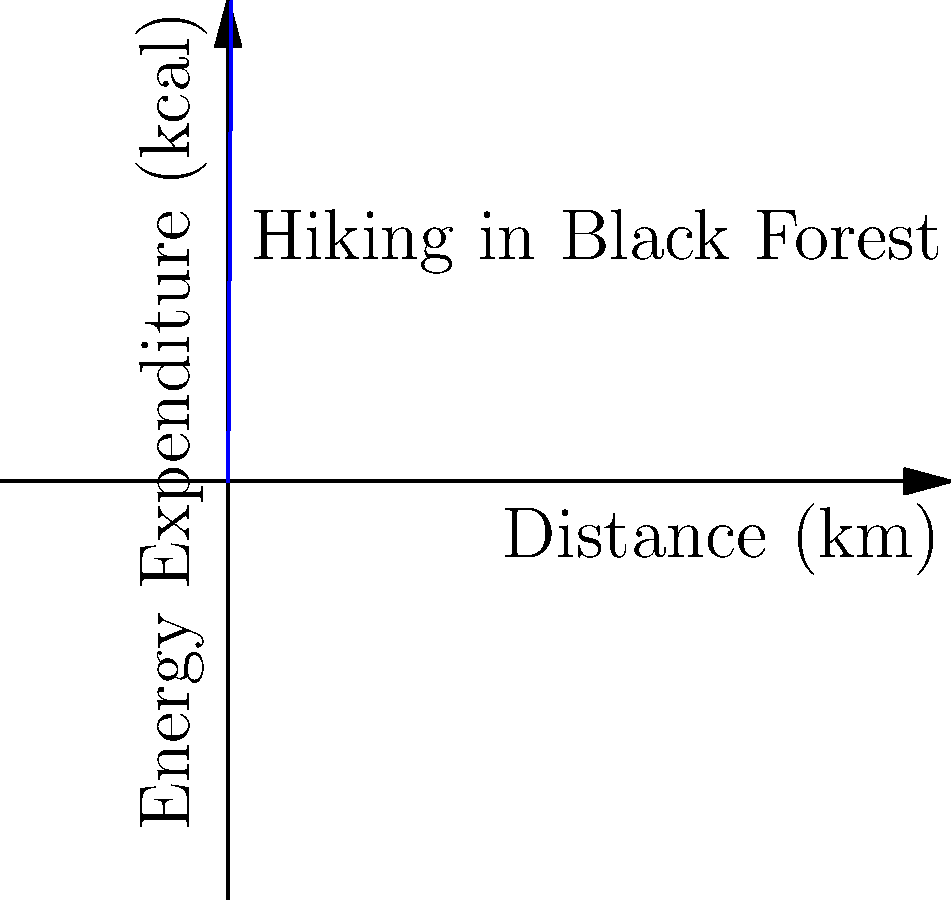Based on the graph showing energy expenditure during hiking in the Black Forest, estimate the approximate calorie burn for a tourist walking 3.5 km. How does this compare to the energy expended climbing 100 stairs in a medieval castle, assuming each step burns about 0.17 kcal? To solve this problem, let's break it down into steps:

1. Analyze the graph for hiking:
   - The graph shows a linear relationship between distance and energy expenditure.
   - We can see that for every 1 km, approximately 150 kcal are burned.

2. Calculate energy expenditure for 3.5 km hike:
   - Energy burned = (150 kcal/km) * 3.5 km
   - Energy burned = 525 kcal

3. Calculate energy expenditure for climbing 100 stairs:
   - Energy per step = 0.17 kcal
   - Total energy = 0.17 kcal * 100 steps
   - Total energy = 17 kcal

4. Compare the two activities:
   - Hiking 3.5 km burns approximately 525 kcal
   - Climbing 100 stairs burns approximately 17 kcal
   - The ratio of energy expenditure is:
     $\frac{525 \text{ kcal}}{17 \text{ kcal}} \approx 30.88$

5. Conclusion:
   Hiking 3.5 km in the Black Forest burns about 31 times more energy than climbing 100 stairs in a medieval castle.
Answer: Hiking 3.5 km burns ~525 kcal, ~31 times more than climbing 100 stairs (17 kcal). 